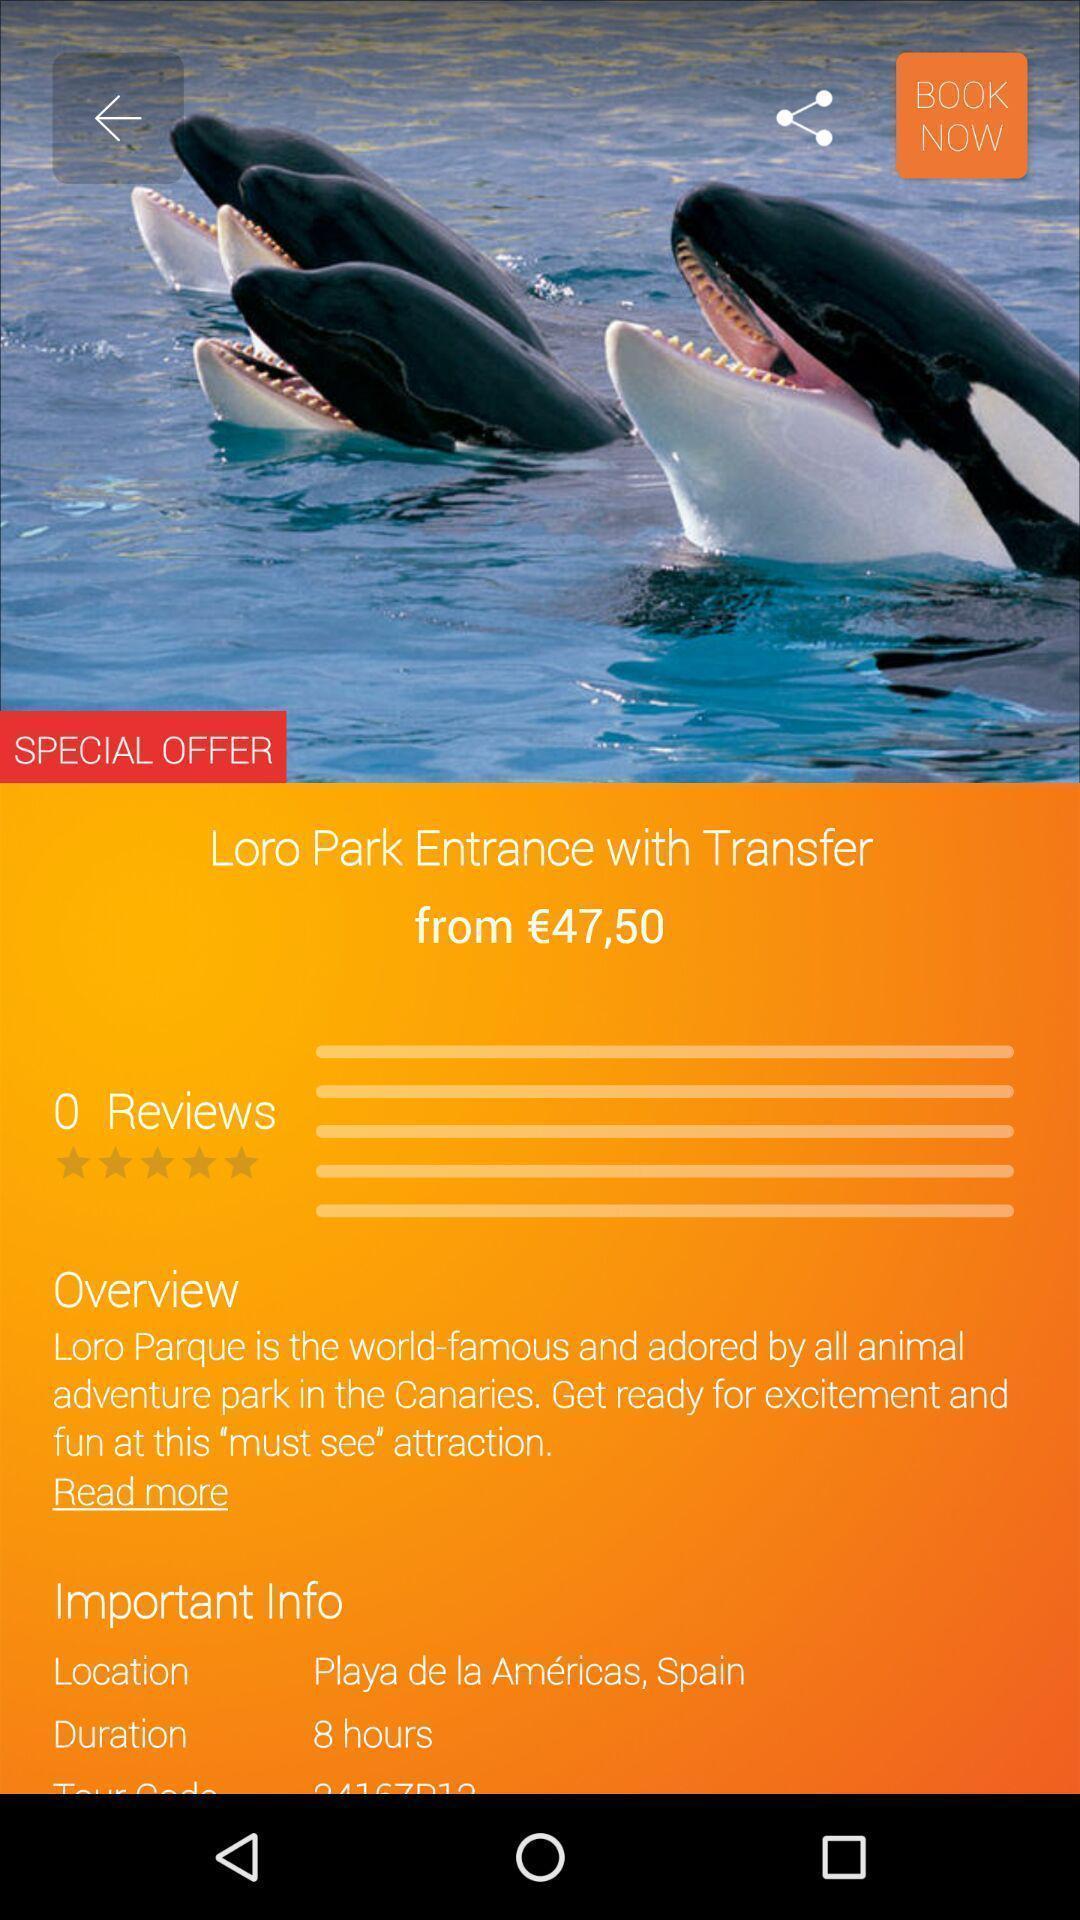Give me a summary of this screen capture. Page showing park details and fee. 